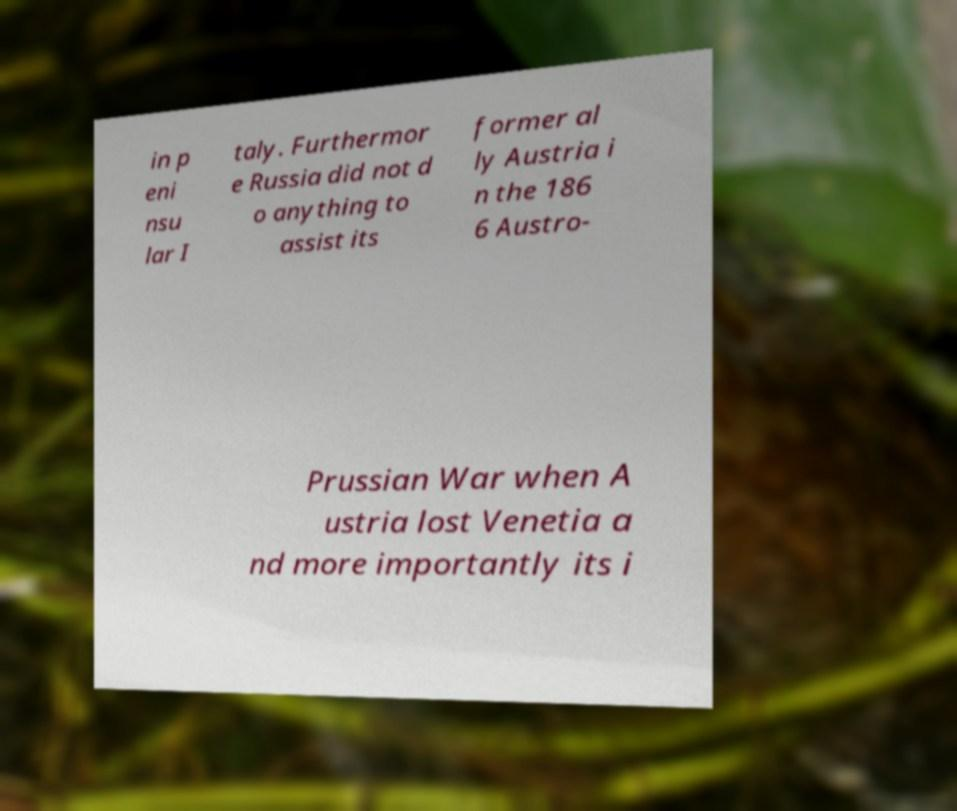Can you read and provide the text displayed in the image?This photo seems to have some interesting text. Can you extract and type it out for me? in p eni nsu lar I taly. Furthermor e Russia did not d o anything to assist its former al ly Austria i n the 186 6 Austro- Prussian War when A ustria lost Venetia a nd more importantly its i 